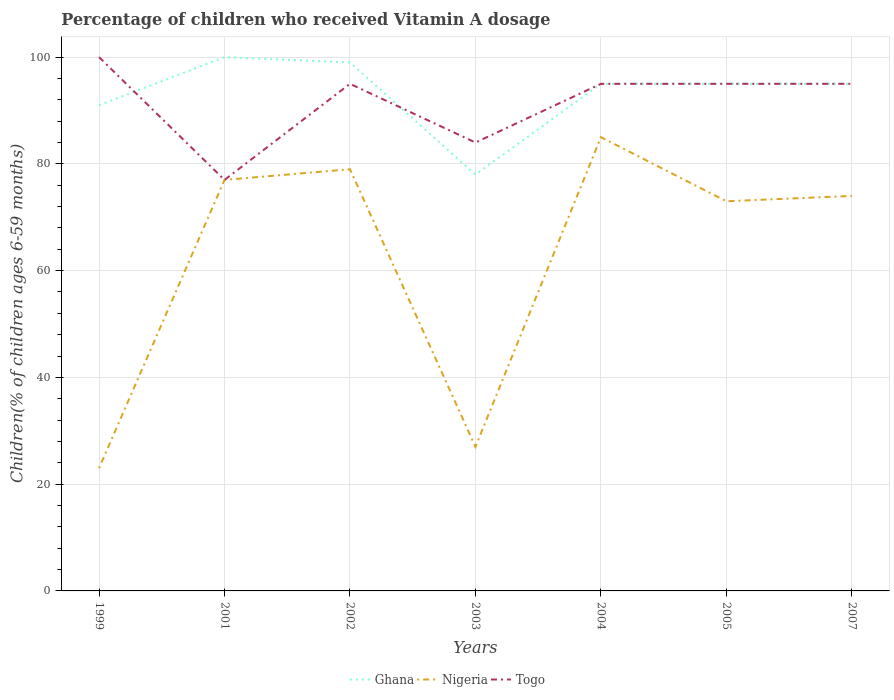Does the line corresponding to Nigeria intersect with the line corresponding to Ghana?
Offer a very short reply. No. Across all years, what is the maximum percentage of children who received Vitamin A dosage in Ghana?
Make the answer very short. 78. What is the total percentage of children who received Vitamin A dosage in Nigeria in the graph?
Your answer should be compact. -4. What is the difference between the highest and the lowest percentage of children who received Vitamin A dosage in Ghana?
Your answer should be very brief. 5. Is the percentage of children who received Vitamin A dosage in Nigeria strictly greater than the percentage of children who received Vitamin A dosage in Togo over the years?
Ensure brevity in your answer.  No. Does the graph contain any zero values?
Your answer should be compact. No. How many legend labels are there?
Provide a short and direct response. 3. How are the legend labels stacked?
Give a very brief answer. Horizontal. What is the title of the graph?
Offer a terse response. Percentage of children who received Vitamin A dosage. What is the label or title of the Y-axis?
Provide a succinct answer. Children(% of children ages 6-59 months). What is the Children(% of children ages 6-59 months) in Ghana in 1999?
Ensure brevity in your answer.  91. What is the Children(% of children ages 6-59 months) of Nigeria in 1999?
Your answer should be compact. 23. What is the Children(% of children ages 6-59 months) in Ghana in 2001?
Your answer should be compact. 100. What is the Children(% of children ages 6-59 months) in Nigeria in 2001?
Ensure brevity in your answer.  77. What is the Children(% of children ages 6-59 months) in Ghana in 2002?
Keep it short and to the point. 99. What is the Children(% of children ages 6-59 months) of Nigeria in 2002?
Your response must be concise. 79. What is the Children(% of children ages 6-59 months) of Ghana in 2003?
Provide a succinct answer. 78. What is the Children(% of children ages 6-59 months) of Nigeria in 2003?
Offer a terse response. 27. What is the Children(% of children ages 6-59 months) of Ghana in 2004?
Your answer should be compact. 95. What is the Children(% of children ages 6-59 months) of Nigeria in 2005?
Offer a terse response. 73. What is the Children(% of children ages 6-59 months) of Ghana in 2007?
Your response must be concise. 95. What is the Children(% of children ages 6-59 months) in Togo in 2007?
Your answer should be compact. 95. Across all years, what is the maximum Children(% of children ages 6-59 months) in Ghana?
Give a very brief answer. 100. Across all years, what is the maximum Children(% of children ages 6-59 months) of Nigeria?
Give a very brief answer. 85. Across all years, what is the maximum Children(% of children ages 6-59 months) in Togo?
Give a very brief answer. 100. Across all years, what is the minimum Children(% of children ages 6-59 months) of Nigeria?
Give a very brief answer. 23. Across all years, what is the minimum Children(% of children ages 6-59 months) of Togo?
Offer a terse response. 77. What is the total Children(% of children ages 6-59 months) of Ghana in the graph?
Offer a very short reply. 653. What is the total Children(% of children ages 6-59 months) of Nigeria in the graph?
Make the answer very short. 438. What is the total Children(% of children ages 6-59 months) of Togo in the graph?
Ensure brevity in your answer.  641. What is the difference between the Children(% of children ages 6-59 months) in Nigeria in 1999 and that in 2001?
Keep it short and to the point. -54. What is the difference between the Children(% of children ages 6-59 months) of Nigeria in 1999 and that in 2002?
Offer a terse response. -56. What is the difference between the Children(% of children ages 6-59 months) in Togo in 1999 and that in 2003?
Your answer should be compact. 16. What is the difference between the Children(% of children ages 6-59 months) in Ghana in 1999 and that in 2004?
Ensure brevity in your answer.  -4. What is the difference between the Children(% of children ages 6-59 months) in Nigeria in 1999 and that in 2004?
Your answer should be very brief. -62. What is the difference between the Children(% of children ages 6-59 months) of Ghana in 1999 and that in 2005?
Make the answer very short. -4. What is the difference between the Children(% of children ages 6-59 months) in Togo in 1999 and that in 2005?
Provide a succinct answer. 5. What is the difference between the Children(% of children ages 6-59 months) in Nigeria in 1999 and that in 2007?
Ensure brevity in your answer.  -51. What is the difference between the Children(% of children ages 6-59 months) in Ghana in 2001 and that in 2002?
Keep it short and to the point. 1. What is the difference between the Children(% of children ages 6-59 months) in Nigeria in 2001 and that in 2002?
Your answer should be very brief. -2. What is the difference between the Children(% of children ages 6-59 months) of Togo in 2001 and that in 2002?
Offer a very short reply. -18. What is the difference between the Children(% of children ages 6-59 months) in Nigeria in 2001 and that in 2003?
Offer a terse response. 50. What is the difference between the Children(% of children ages 6-59 months) of Togo in 2001 and that in 2003?
Your response must be concise. -7. What is the difference between the Children(% of children ages 6-59 months) of Ghana in 2001 and that in 2004?
Ensure brevity in your answer.  5. What is the difference between the Children(% of children ages 6-59 months) in Nigeria in 2001 and that in 2004?
Your answer should be very brief. -8. What is the difference between the Children(% of children ages 6-59 months) in Ghana in 2001 and that in 2005?
Offer a very short reply. 5. What is the difference between the Children(% of children ages 6-59 months) in Nigeria in 2001 and that in 2005?
Your answer should be very brief. 4. What is the difference between the Children(% of children ages 6-59 months) of Togo in 2001 and that in 2005?
Provide a short and direct response. -18. What is the difference between the Children(% of children ages 6-59 months) in Nigeria in 2001 and that in 2007?
Provide a short and direct response. 3. What is the difference between the Children(% of children ages 6-59 months) in Togo in 2001 and that in 2007?
Make the answer very short. -18. What is the difference between the Children(% of children ages 6-59 months) in Nigeria in 2002 and that in 2003?
Your answer should be very brief. 52. What is the difference between the Children(% of children ages 6-59 months) in Nigeria in 2002 and that in 2004?
Provide a short and direct response. -6. What is the difference between the Children(% of children ages 6-59 months) in Nigeria in 2002 and that in 2005?
Offer a terse response. 6. What is the difference between the Children(% of children ages 6-59 months) of Togo in 2002 and that in 2005?
Offer a terse response. 0. What is the difference between the Children(% of children ages 6-59 months) of Ghana in 2003 and that in 2004?
Your response must be concise. -17. What is the difference between the Children(% of children ages 6-59 months) in Nigeria in 2003 and that in 2004?
Offer a very short reply. -58. What is the difference between the Children(% of children ages 6-59 months) of Togo in 2003 and that in 2004?
Offer a terse response. -11. What is the difference between the Children(% of children ages 6-59 months) in Ghana in 2003 and that in 2005?
Your answer should be very brief. -17. What is the difference between the Children(% of children ages 6-59 months) of Nigeria in 2003 and that in 2005?
Keep it short and to the point. -46. What is the difference between the Children(% of children ages 6-59 months) of Togo in 2003 and that in 2005?
Keep it short and to the point. -11. What is the difference between the Children(% of children ages 6-59 months) of Ghana in 2003 and that in 2007?
Your answer should be compact. -17. What is the difference between the Children(% of children ages 6-59 months) in Nigeria in 2003 and that in 2007?
Ensure brevity in your answer.  -47. What is the difference between the Children(% of children ages 6-59 months) of Ghana in 2004 and that in 2005?
Offer a terse response. 0. What is the difference between the Children(% of children ages 6-59 months) in Togo in 2004 and that in 2005?
Ensure brevity in your answer.  0. What is the difference between the Children(% of children ages 6-59 months) of Ghana in 2004 and that in 2007?
Give a very brief answer. 0. What is the difference between the Children(% of children ages 6-59 months) of Togo in 2004 and that in 2007?
Ensure brevity in your answer.  0. What is the difference between the Children(% of children ages 6-59 months) in Nigeria in 2005 and that in 2007?
Ensure brevity in your answer.  -1. What is the difference between the Children(% of children ages 6-59 months) of Togo in 2005 and that in 2007?
Give a very brief answer. 0. What is the difference between the Children(% of children ages 6-59 months) of Ghana in 1999 and the Children(% of children ages 6-59 months) of Togo in 2001?
Offer a terse response. 14. What is the difference between the Children(% of children ages 6-59 months) in Nigeria in 1999 and the Children(% of children ages 6-59 months) in Togo in 2001?
Offer a very short reply. -54. What is the difference between the Children(% of children ages 6-59 months) in Nigeria in 1999 and the Children(% of children ages 6-59 months) in Togo in 2002?
Offer a very short reply. -72. What is the difference between the Children(% of children ages 6-59 months) in Ghana in 1999 and the Children(% of children ages 6-59 months) in Nigeria in 2003?
Provide a succinct answer. 64. What is the difference between the Children(% of children ages 6-59 months) in Ghana in 1999 and the Children(% of children ages 6-59 months) in Togo in 2003?
Offer a very short reply. 7. What is the difference between the Children(% of children ages 6-59 months) in Nigeria in 1999 and the Children(% of children ages 6-59 months) in Togo in 2003?
Offer a very short reply. -61. What is the difference between the Children(% of children ages 6-59 months) of Nigeria in 1999 and the Children(% of children ages 6-59 months) of Togo in 2004?
Your response must be concise. -72. What is the difference between the Children(% of children ages 6-59 months) in Ghana in 1999 and the Children(% of children ages 6-59 months) in Togo in 2005?
Offer a terse response. -4. What is the difference between the Children(% of children ages 6-59 months) of Nigeria in 1999 and the Children(% of children ages 6-59 months) of Togo in 2005?
Provide a short and direct response. -72. What is the difference between the Children(% of children ages 6-59 months) in Ghana in 1999 and the Children(% of children ages 6-59 months) in Togo in 2007?
Ensure brevity in your answer.  -4. What is the difference between the Children(% of children ages 6-59 months) in Nigeria in 1999 and the Children(% of children ages 6-59 months) in Togo in 2007?
Your answer should be very brief. -72. What is the difference between the Children(% of children ages 6-59 months) in Ghana in 2001 and the Children(% of children ages 6-59 months) in Nigeria in 2002?
Offer a very short reply. 21. What is the difference between the Children(% of children ages 6-59 months) in Ghana in 2001 and the Children(% of children ages 6-59 months) in Togo in 2002?
Give a very brief answer. 5. What is the difference between the Children(% of children ages 6-59 months) of Nigeria in 2001 and the Children(% of children ages 6-59 months) of Togo in 2002?
Offer a terse response. -18. What is the difference between the Children(% of children ages 6-59 months) in Ghana in 2001 and the Children(% of children ages 6-59 months) in Togo in 2003?
Ensure brevity in your answer.  16. What is the difference between the Children(% of children ages 6-59 months) in Nigeria in 2001 and the Children(% of children ages 6-59 months) in Togo in 2003?
Provide a short and direct response. -7. What is the difference between the Children(% of children ages 6-59 months) of Ghana in 2001 and the Children(% of children ages 6-59 months) of Togo in 2005?
Your response must be concise. 5. What is the difference between the Children(% of children ages 6-59 months) in Nigeria in 2001 and the Children(% of children ages 6-59 months) in Togo in 2005?
Make the answer very short. -18. What is the difference between the Children(% of children ages 6-59 months) of Ghana in 2001 and the Children(% of children ages 6-59 months) of Nigeria in 2007?
Offer a very short reply. 26. What is the difference between the Children(% of children ages 6-59 months) of Ghana in 2001 and the Children(% of children ages 6-59 months) of Togo in 2007?
Make the answer very short. 5. What is the difference between the Children(% of children ages 6-59 months) of Nigeria in 2001 and the Children(% of children ages 6-59 months) of Togo in 2007?
Your response must be concise. -18. What is the difference between the Children(% of children ages 6-59 months) of Ghana in 2002 and the Children(% of children ages 6-59 months) of Nigeria in 2003?
Keep it short and to the point. 72. What is the difference between the Children(% of children ages 6-59 months) in Ghana in 2002 and the Children(% of children ages 6-59 months) in Togo in 2003?
Make the answer very short. 15. What is the difference between the Children(% of children ages 6-59 months) in Nigeria in 2002 and the Children(% of children ages 6-59 months) in Togo in 2003?
Give a very brief answer. -5. What is the difference between the Children(% of children ages 6-59 months) of Ghana in 2002 and the Children(% of children ages 6-59 months) of Nigeria in 2004?
Make the answer very short. 14. What is the difference between the Children(% of children ages 6-59 months) in Ghana in 2002 and the Children(% of children ages 6-59 months) in Togo in 2004?
Give a very brief answer. 4. What is the difference between the Children(% of children ages 6-59 months) of Nigeria in 2002 and the Children(% of children ages 6-59 months) of Togo in 2004?
Make the answer very short. -16. What is the difference between the Children(% of children ages 6-59 months) of Nigeria in 2002 and the Children(% of children ages 6-59 months) of Togo in 2007?
Give a very brief answer. -16. What is the difference between the Children(% of children ages 6-59 months) of Ghana in 2003 and the Children(% of children ages 6-59 months) of Nigeria in 2004?
Your response must be concise. -7. What is the difference between the Children(% of children ages 6-59 months) in Nigeria in 2003 and the Children(% of children ages 6-59 months) in Togo in 2004?
Your response must be concise. -68. What is the difference between the Children(% of children ages 6-59 months) of Ghana in 2003 and the Children(% of children ages 6-59 months) of Nigeria in 2005?
Ensure brevity in your answer.  5. What is the difference between the Children(% of children ages 6-59 months) in Nigeria in 2003 and the Children(% of children ages 6-59 months) in Togo in 2005?
Give a very brief answer. -68. What is the difference between the Children(% of children ages 6-59 months) of Nigeria in 2003 and the Children(% of children ages 6-59 months) of Togo in 2007?
Offer a terse response. -68. What is the difference between the Children(% of children ages 6-59 months) in Ghana in 2004 and the Children(% of children ages 6-59 months) in Nigeria in 2005?
Your answer should be compact. 22. What is the difference between the Children(% of children ages 6-59 months) of Nigeria in 2004 and the Children(% of children ages 6-59 months) of Togo in 2005?
Your answer should be compact. -10. What is the difference between the Children(% of children ages 6-59 months) in Ghana in 2004 and the Children(% of children ages 6-59 months) in Nigeria in 2007?
Your answer should be compact. 21. What is the average Children(% of children ages 6-59 months) of Ghana per year?
Provide a short and direct response. 93.29. What is the average Children(% of children ages 6-59 months) in Nigeria per year?
Keep it short and to the point. 62.57. What is the average Children(% of children ages 6-59 months) in Togo per year?
Provide a short and direct response. 91.57. In the year 1999, what is the difference between the Children(% of children ages 6-59 months) in Ghana and Children(% of children ages 6-59 months) in Nigeria?
Make the answer very short. 68. In the year 1999, what is the difference between the Children(% of children ages 6-59 months) in Nigeria and Children(% of children ages 6-59 months) in Togo?
Give a very brief answer. -77. In the year 2001, what is the difference between the Children(% of children ages 6-59 months) of Ghana and Children(% of children ages 6-59 months) of Nigeria?
Offer a very short reply. 23. In the year 2001, what is the difference between the Children(% of children ages 6-59 months) in Ghana and Children(% of children ages 6-59 months) in Togo?
Provide a succinct answer. 23. In the year 2002, what is the difference between the Children(% of children ages 6-59 months) in Ghana and Children(% of children ages 6-59 months) in Nigeria?
Offer a terse response. 20. In the year 2002, what is the difference between the Children(% of children ages 6-59 months) in Ghana and Children(% of children ages 6-59 months) in Togo?
Provide a short and direct response. 4. In the year 2002, what is the difference between the Children(% of children ages 6-59 months) in Nigeria and Children(% of children ages 6-59 months) in Togo?
Provide a short and direct response. -16. In the year 2003, what is the difference between the Children(% of children ages 6-59 months) in Ghana and Children(% of children ages 6-59 months) in Nigeria?
Make the answer very short. 51. In the year 2003, what is the difference between the Children(% of children ages 6-59 months) in Nigeria and Children(% of children ages 6-59 months) in Togo?
Keep it short and to the point. -57. In the year 2004, what is the difference between the Children(% of children ages 6-59 months) of Ghana and Children(% of children ages 6-59 months) of Togo?
Your response must be concise. 0. In the year 2005, what is the difference between the Children(% of children ages 6-59 months) in Nigeria and Children(% of children ages 6-59 months) in Togo?
Provide a succinct answer. -22. In the year 2007, what is the difference between the Children(% of children ages 6-59 months) in Ghana and Children(% of children ages 6-59 months) in Nigeria?
Offer a very short reply. 21. What is the ratio of the Children(% of children ages 6-59 months) in Ghana in 1999 to that in 2001?
Keep it short and to the point. 0.91. What is the ratio of the Children(% of children ages 6-59 months) in Nigeria in 1999 to that in 2001?
Your answer should be very brief. 0.3. What is the ratio of the Children(% of children ages 6-59 months) in Togo in 1999 to that in 2001?
Give a very brief answer. 1.3. What is the ratio of the Children(% of children ages 6-59 months) in Ghana in 1999 to that in 2002?
Give a very brief answer. 0.92. What is the ratio of the Children(% of children ages 6-59 months) of Nigeria in 1999 to that in 2002?
Ensure brevity in your answer.  0.29. What is the ratio of the Children(% of children ages 6-59 months) of Togo in 1999 to that in 2002?
Provide a short and direct response. 1.05. What is the ratio of the Children(% of children ages 6-59 months) of Nigeria in 1999 to that in 2003?
Offer a very short reply. 0.85. What is the ratio of the Children(% of children ages 6-59 months) of Togo in 1999 to that in 2003?
Give a very brief answer. 1.19. What is the ratio of the Children(% of children ages 6-59 months) of Ghana in 1999 to that in 2004?
Keep it short and to the point. 0.96. What is the ratio of the Children(% of children ages 6-59 months) of Nigeria in 1999 to that in 2004?
Keep it short and to the point. 0.27. What is the ratio of the Children(% of children ages 6-59 months) of Togo in 1999 to that in 2004?
Provide a short and direct response. 1.05. What is the ratio of the Children(% of children ages 6-59 months) of Ghana in 1999 to that in 2005?
Offer a terse response. 0.96. What is the ratio of the Children(% of children ages 6-59 months) in Nigeria in 1999 to that in 2005?
Keep it short and to the point. 0.32. What is the ratio of the Children(% of children ages 6-59 months) of Togo in 1999 to that in 2005?
Ensure brevity in your answer.  1.05. What is the ratio of the Children(% of children ages 6-59 months) in Ghana in 1999 to that in 2007?
Offer a very short reply. 0.96. What is the ratio of the Children(% of children ages 6-59 months) in Nigeria in 1999 to that in 2007?
Your answer should be very brief. 0.31. What is the ratio of the Children(% of children ages 6-59 months) of Togo in 1999 to that in 2007?
Offer a terse response. 1.05. What is the ratio of the Children(% of children ages 6-59 months) of Nigeria in 2001 to that in 2002?
Your answer should be compact. 0.97. What is the ratio of the Children(% of children ages 6-59 months) of Togo in 2001 to that in 2002?
Provide a succinct answer. 0.81. What is the ratio of the Children(% of children ages 6-59 months) of Ghana in 2001 to that in 2003?
Your answer should be compact. 1.28. What is the ratio of the Children(% of children ages 6-59 months) in Nigeria in 2001 to that in 2003?
Keep it short and to the point. 2.85. What is the ratio of the Children(% of children ages 6-59 months) of Togo in 2001 to that in 2003?
Offer a terse response. 0.92. What is the ratio of the Children(% of children ages 6-59 months) in Ghana in 2001 to that in 2004?
Provide a succinct answer. 1.05. What is the ratio of the Children(% of children ages 6-59 months) of Nigeria in 2001 to that in 2004?
Ensure brevity in your answer.  0.91. What is the ratio of the Children(% of children ages 6-59 months) of Togo in 2001 to that in 2004?
Give a very brief answer. 0.81. What is the ratio of the Children(% of children ages 6-59 months) in Ghana in 2001 to that in 2005?
Offer a terse response. 1.05. What is the ratio of the Children(% of children ages 6-59 months) of Nigeria in 2001 to that in 2005?
Make the answer very short. 1.05. What is the ratio of the Children(% of children ages 6-59 months) in Togo in 2001 to that in 2005?
Make the answer very short. 0.81. What is the ratio of the Children(% of children ages 6-59 months) in Ghana in 2001 to that in 2007?
Ensure brevity in your answer.  1.05. What is the ratio of the Children(% of children ages 6-59 months) of Nigeria in 2001 to that in 2007?
Provide a short and direct response. 1.04. What is the ratio of the Children(% of children ages 6-59 months) of Togo in 2001 to that in 2007?
Your answer should be compact. 0.81. What is the ratio of the Children(% of children ages 6-59 months) in Ghana in 2002 to that in 2003?
Your answer should be compact. 1.27. What is the ratio of the Children(% of children ages 6-59 months) in Nigeria in 2002 to that in 2003?
Offer a terse response. 2.93. What is the ratio of the Children(% of children ages 6-59 months) in Togo in 2002 to that in 2003?
Your response must be concise. 1.13. What is the ratio of the Children(% of children ages 6-59 months) in Ghana in 2002 to that in 2004?
Keep it short and to the point. 1.04. What is the ratio of the Children(% of children ages 6-59 months) of Nigeria in 2002 to that in 2004?
Ensure brevity in your answer.  0.93. What is the ratio of the Children(% of children ages 6-59 months) of Togo in 2002 to that in 2004?
Give a very brief answer. 1. What is the ratio of the Children(% of children ages 6-59 months) of Ghana in 2002 to that in 2005?
Keep it short and to the point. 1.04. What is the ratio of the Children(% of children ages 6-59 months) in Nigeria in 2002 to that in 2005?
Offer a very short reply. 1.08. What is the ratio of the Children(% of children ages 6-59 months) of Togo in 2002 to that in 2005?
Give a very brief answer. 1. What is the ratio of the Children(% of children ages 6-59 months) of Ghana in 2002 to that in 2007?
Your response must be concise. 1.04. What is the ratio of the Children(% of children ages 6-59 months) in Nigeria in 2002 to that in 2007?
Your answer should be compact. 1.07. What is the ratio of the Children(% of children ages 6-59 months) of Togo in 2002 to that in 2007?
Offer a terse response. 1. What is the ratio of the Children(% of children ages 6-59 months) in Ghana in 2003 to that in 2004?
Your answer should be compact. 0.82. What is the ratio of the Children(% of children ages 6-59 months) in Nigeria in 2003 to that in 2004?
Offer a terse response. 0.32. What is the ratio of the Children(% of children ages 6-59 months) of Togo in 2003 to that in 2004?
Your answer should be compact. 0.88. What is the ratio of the Children(% of children ages 6-59 months) of Ghana in 2003 to that in 2005?
Give a very brief answer. 0.82. What is the ratio of the Children(% of children ages 6-59 months) of Nigeria in 2003 to that in 2005?
Provide a short and direct response. 0.37. What is the ratio of the Children(% of children ages 6-59 months) of Togo in 2003 to that in 2005?
Your answer should be very brief. 0.88. What is the ratio of the Children(% of children ages 6-59 months) of Ghana in 2003 to that in 2007?
Keep it short and to the point. 0.82. What is the ratio of the Children(% of children ages 6-59 months) of Nigeria in 2003 to that in 2007?
Offer a terse response. 0.36. What is the ratio of the Children(% of children ages 6-59 months) in Togo in 2003 to that in 2007?
Keep it short and to the point. 0.88. What is the ratio of the Children(% of children ages 6-59 months) of Nigeria in 2004 to that in 2005?
Your answer should be compact. 1.16. What is the ratio of the Children(% of children ages 6-59 months) of Togo in 2004 to that in 2005?
Offer a terse response. 1. What is the ratio of the Children(% of children ages 6-59 months) of Nigeria in 2004 to that in 2007?
Your response must be concise. 1.15. What is the ratio of the Children(% of children ages 6-59 months) in Ghana in 2005 to that in 2007?
Give a very brief answer. 1. What is the ratio of the Children(% of children ages 6-59 months) of Nigeria in 2005 to that in 2007?
Offer a terse response. 0.99. What is the difference between the highest and the second highest Children(% of children ages 6-59 months) of Togo?
Offer a very short reply. 5. What is the difference between the highest and the lowest Children(% of children ages 6-59 months) of Nigeria?
Provide a succinct answer. 62. What is the difference between the highest and the lowest Children(% of children ages 6-59 months) in Togo?
Give a very brief answer. 23. 